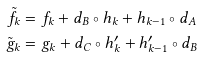<formula> <loc_0><loc_0><loc_500><loc_500>\tilde { f } _ { k } & = f _ { k } + d _ { B } \circ h _ { k } + h _ { k - 1 } \circ d _ { A } \\ \tilde { g } _ { k } & = g _ { k } + d _ { C } \circ h ^ { \prime } _ { k } + h ^ { \prime } _ { k - 1 } \circ d _ { B }</formula> 